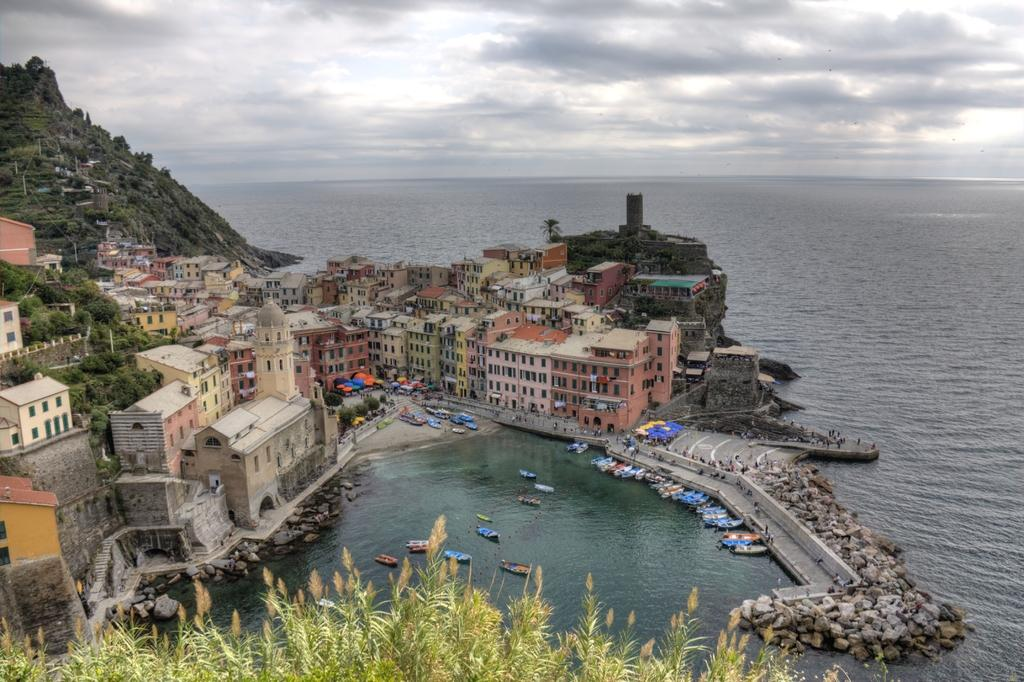What type of landscape is shown in the image? The image depicts a city beside the sea. What structures can be seen in the city? There are many buildings and houses in the city. What can be found at the seashore? There are boats at the seashore. What natural feature is visible behind the city? There is a huge mountain behind the city. What type of tramp can be seen jumping over the mountain in the image? There is no tramp present in the image, and no one is jumping over the mountain. What appliance is being used to cook food in the image? There is no appliance visible in the image, as it focuses on the city, sea, boats, and mountain. 